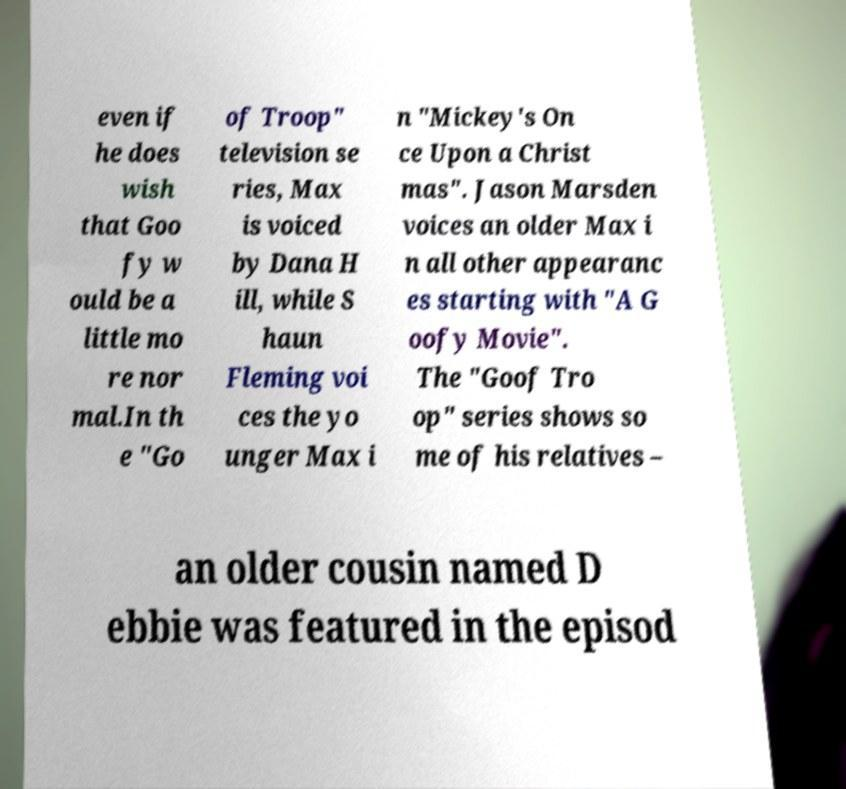For documentation purposes, I need the text within this image transcribed. Could you provide that? even if he does wish that Goo fy w ould be a little mo re nor mal.In th e "Go of Troop" television se ries, Max is voiced by Dana H ill, while S haun Fleming voi ces the yo unger Max i n "Mickey's On ce Upon a Christ mas". Jason Marsden voices an older Max i n all other appearanc es starting with "A G oofy Movie". The "Goof Tro op" series shows so me of his relatives – an older cousin named D ebbie was featured in the episod 